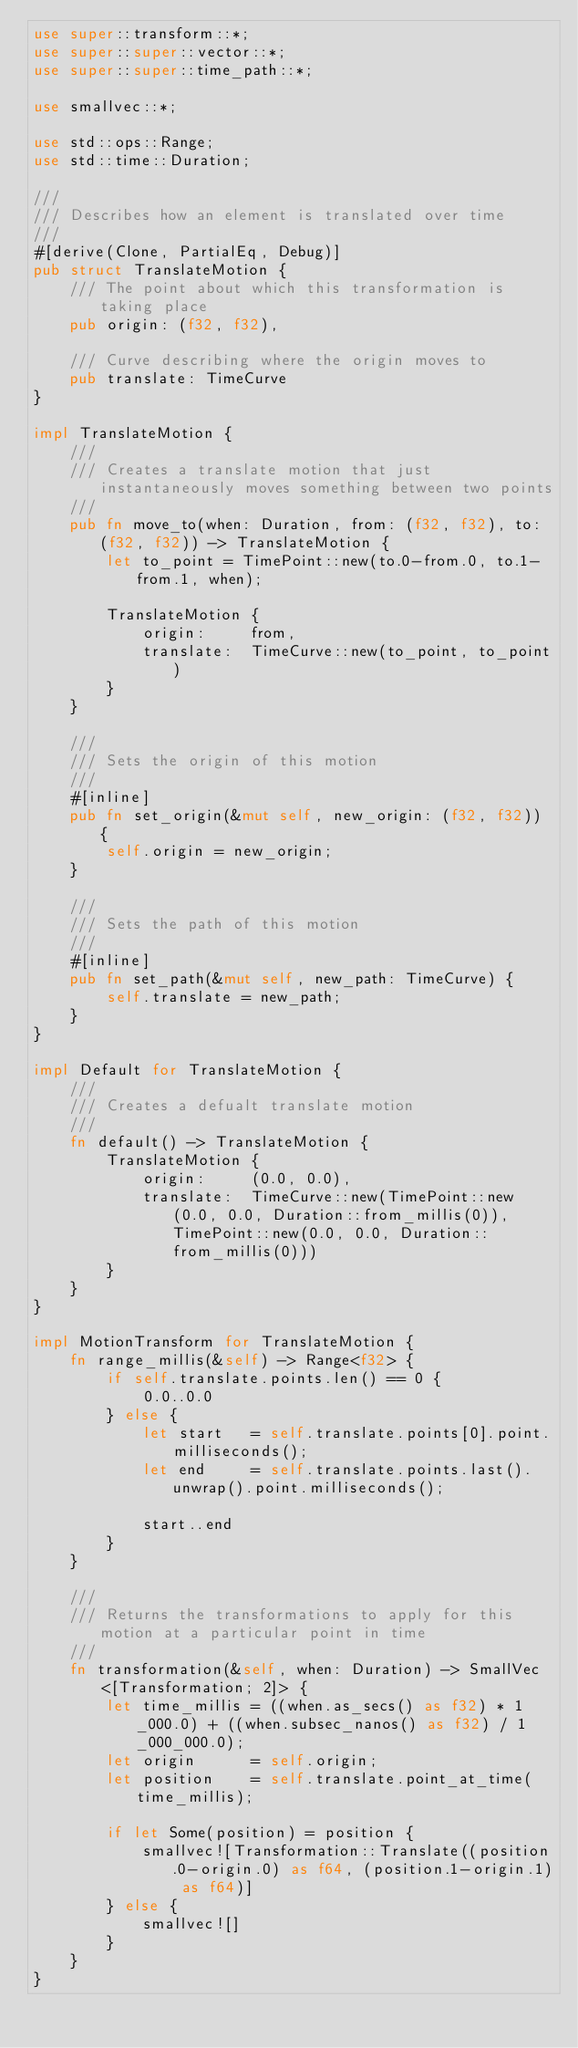Convert code to text. <code><loc_0><loc_0><loc_500><loc_500><_Rust_>use super::transform::*;
use super::super::vector::*;
use super::super::time_path::*;

use smallvec::*;

use std::ops::Range;
use std::time::Duration;

///
/// Describes how an element is translated over time
///
#[derive(Clone, PartialEq, Debug)]
pub struct TranslateMotion {
    /// The point about which this transformation is taking place
    pub origin: (f32, f32),

    /// Curve describing where the origin moves to
    pub translate: TimeCurve
}

impl TranslateMotion {
    ///
    /// Creates a translate motion that just instantaneously moves something between two points
    ///
    pub fn move_to(when: Duration, from: (f32, f32), to: (f32, f32)) -> TranslateMotion {
        let to_point = TimePoint::new(to.0-from.0, to.1-from.1, when);

        TranslateMotion {
            origin:     from,
            translate:  TimeCurve::new(to_point, to_point)
        }
    }

    ///
    /// Sets the origin of this motion
    ///
    #[inline]
    pub fn set_origin(&mut self, new_origin: (f32, f32)) {
        self.origin = new_origin;
    }

    ///
    /// Sets the path of this motion
    ///
    #[inline]
    pub fn set_path(&mut self, new_path: TimeCurve) {
        self.translate = new_path;
    }
}

impl Default for TranslateMotion {
    ///
    /// Creates a defualt translate motion
    ///
    fn default() -> TranslateMotion {
        TranslateMotion {
            origin:     (0.0, 0.0),
            translate:  TimeCurve::new(TimePoint::new(0.0, 0.0, Duration::from_millis(0)), TimePoint::new(0.0, 0.0, Duration::from_millis(0)))
        }
    }
}

impl MotionTransform for TranslateMotion {
    fn range_millis(&self) -> Range<f32> {
        if self.translate.points.len() == 0 {
            0.0..0.0
        } else {
            let start   = self.translate.points[0].point.milliseconds();
            let end     = self.translate.points.last().unwrap().point.milliseconds();

            start..end
        }
    }

    ///
    /// Returns the transformations to apply for this motion at a particular point in time
    ///
    fn transformation(&self, when: Duration) -> SmallVec<[Transformation; 2]> {
        let time_millis = ((when.as_secs() as f32) * 1_000.0) + ((when.subsec_nanos() as f32) / 1_000_000.0);
        let origin      = self.origin;
        let position    = self.translate.point_at_time(time_millis);

        if let Some(position) = position {
            smallvec![Transformation::Translate((position.0-origin.0) as f64, (position.1-origin.1) as f64)]
        } else {
            smallvec![]
        }
    }
}
</code> 